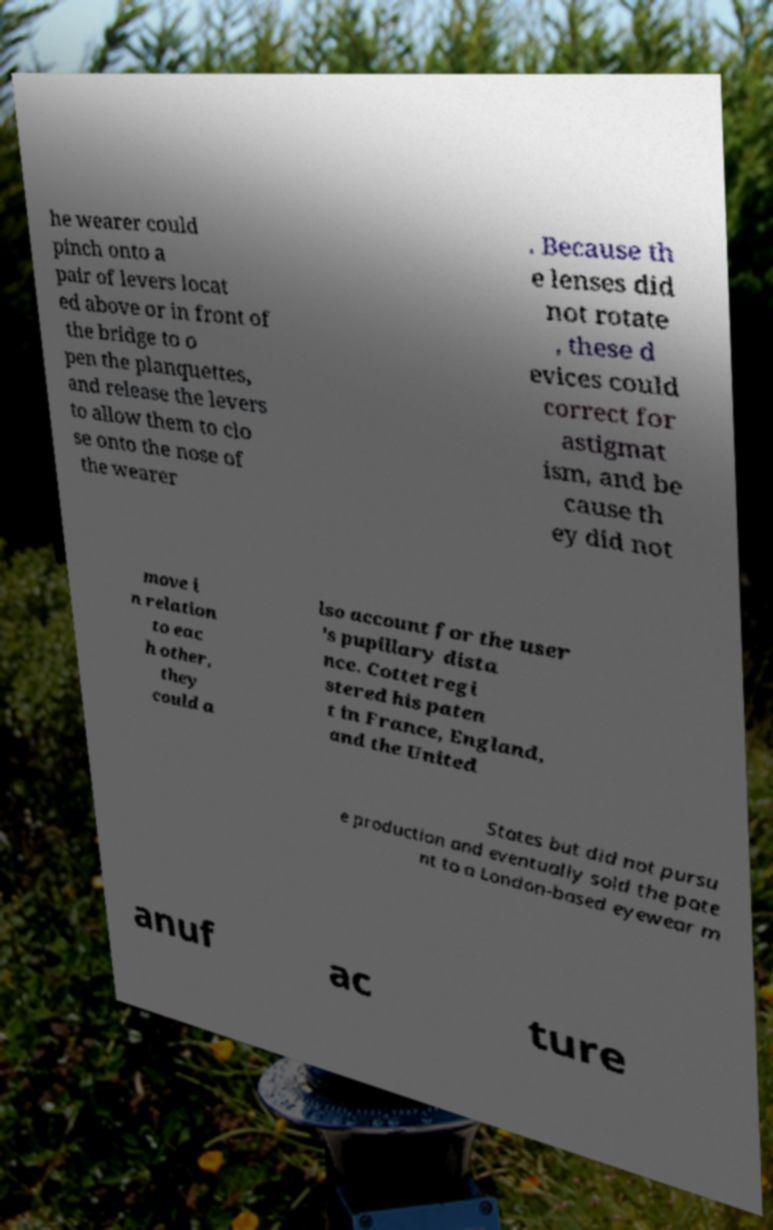What messages or text are displayed in this image? I need them in a readable, typed format. he wearer could pinch onto a pair of levers locat ed above or in front of the bridge to o pen the planquettes, and release the levers to allow them to clo se onto the nose of the wearer . Because th e lenses did not rotate , these d evices could correct for astigmat ism, and be cause th ey did not move i n relation to eac h other, they could a lso account for the user 's pupillary dista nce. Cottet regi stered his paten t in France, England, and the United States but did not pursu e production and eventually sold the pate nt to a London-based eyewear m anuf ac ture 